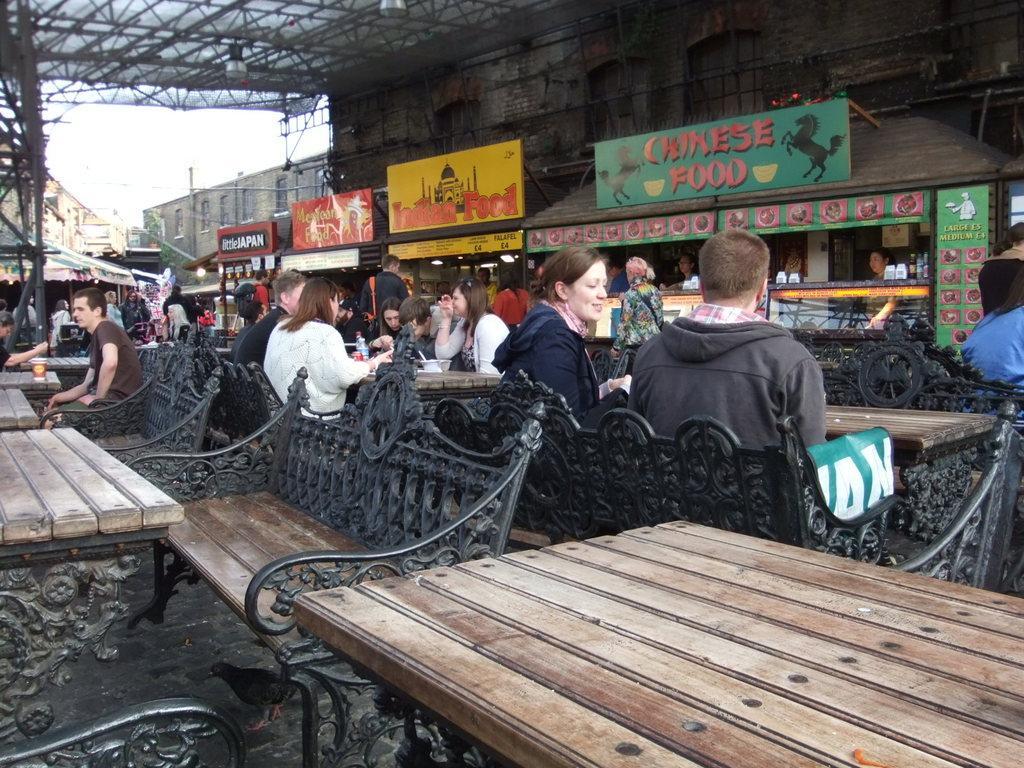Could you give a brief overview of what you see in this image? In this image I see number of buildings and I see few boards on which there is something written and I see number of people who are sitting on benches and I see the tables. In the background I see the sky. 